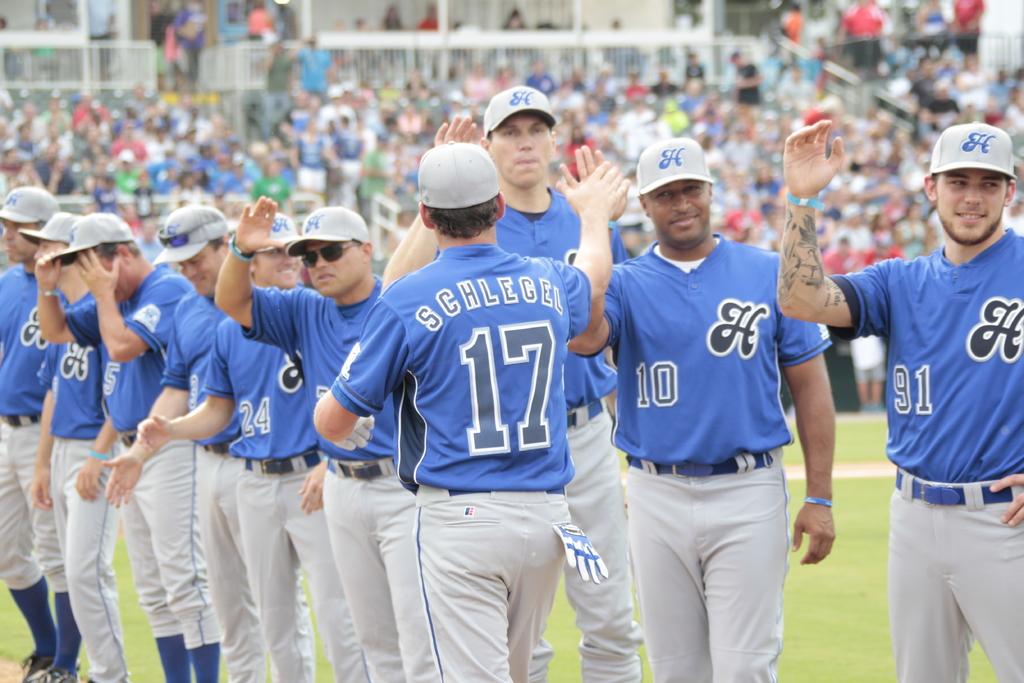What number is schleger?
Your answer should be very brief. 17. What number does the man with tattoos on his forearm wear?
Ensure brevity in your answer.  91. 